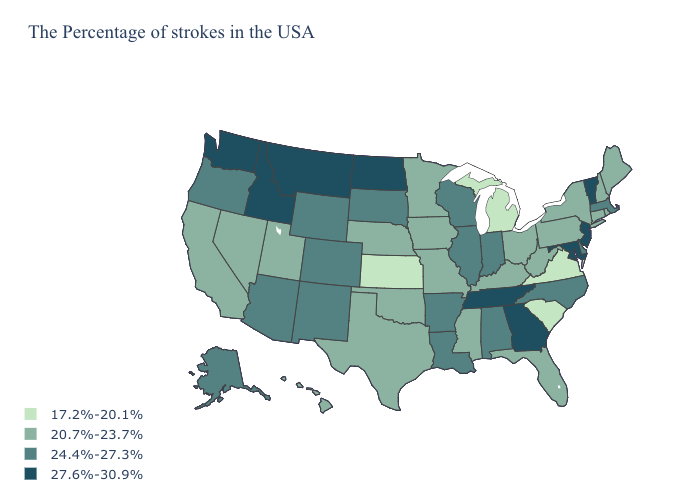What is the value of Wisconsin?
Write a very short answer. 24.4%-27.3%. What is the value of Montana?
Give a very brief answer. 27.6%-30.9%. What is the value of Wisconsin?
Short answer required. 24.4%-27.3%. Does Washington have a higher value than New Jersey?
Short answer required. No. Does the map have missing data?
Give a very brief answer. No. Does Kansas have the lowest value in the MidWest?
Write a very short answer. Yes. Which states have the lowest value in the USA?
Keep it brief. Virginia, South Carolina, Michigan, Kansas. Is the legend a continuous bar?
Quick response, please. No. What is the value of Oklahoma?
Concise answer only. 20.7%-23.7%. Name the states that have a value in the range 24.4%-27.3%?
Answer briefly. Massachusetts, Delaware, North Carolina, Indiana, Alabama, Wisconsin, Illinois, Louisiana, Arkansas, South Dakota, Wyoming, Colorado, New Mexico, Arizona, Oregon, Alaska. Does the first symbol in the legend represent the smallest category?
Keep it brief. Yes. What is the value of New Mexico?
Quick response, please. 24.4%-27.3%. Which states have the highest value in the USA?
Quick response, please. Vermont, New Jersey, Maryland, Georgia, Tennessee, North Dakota, Montana, Idaho, Washington. Does the first symbol in the legend represent the smallest category?
Keep it brief. Yes. Does New Mexico have a lower value than New York?
Answer briefly. No. 